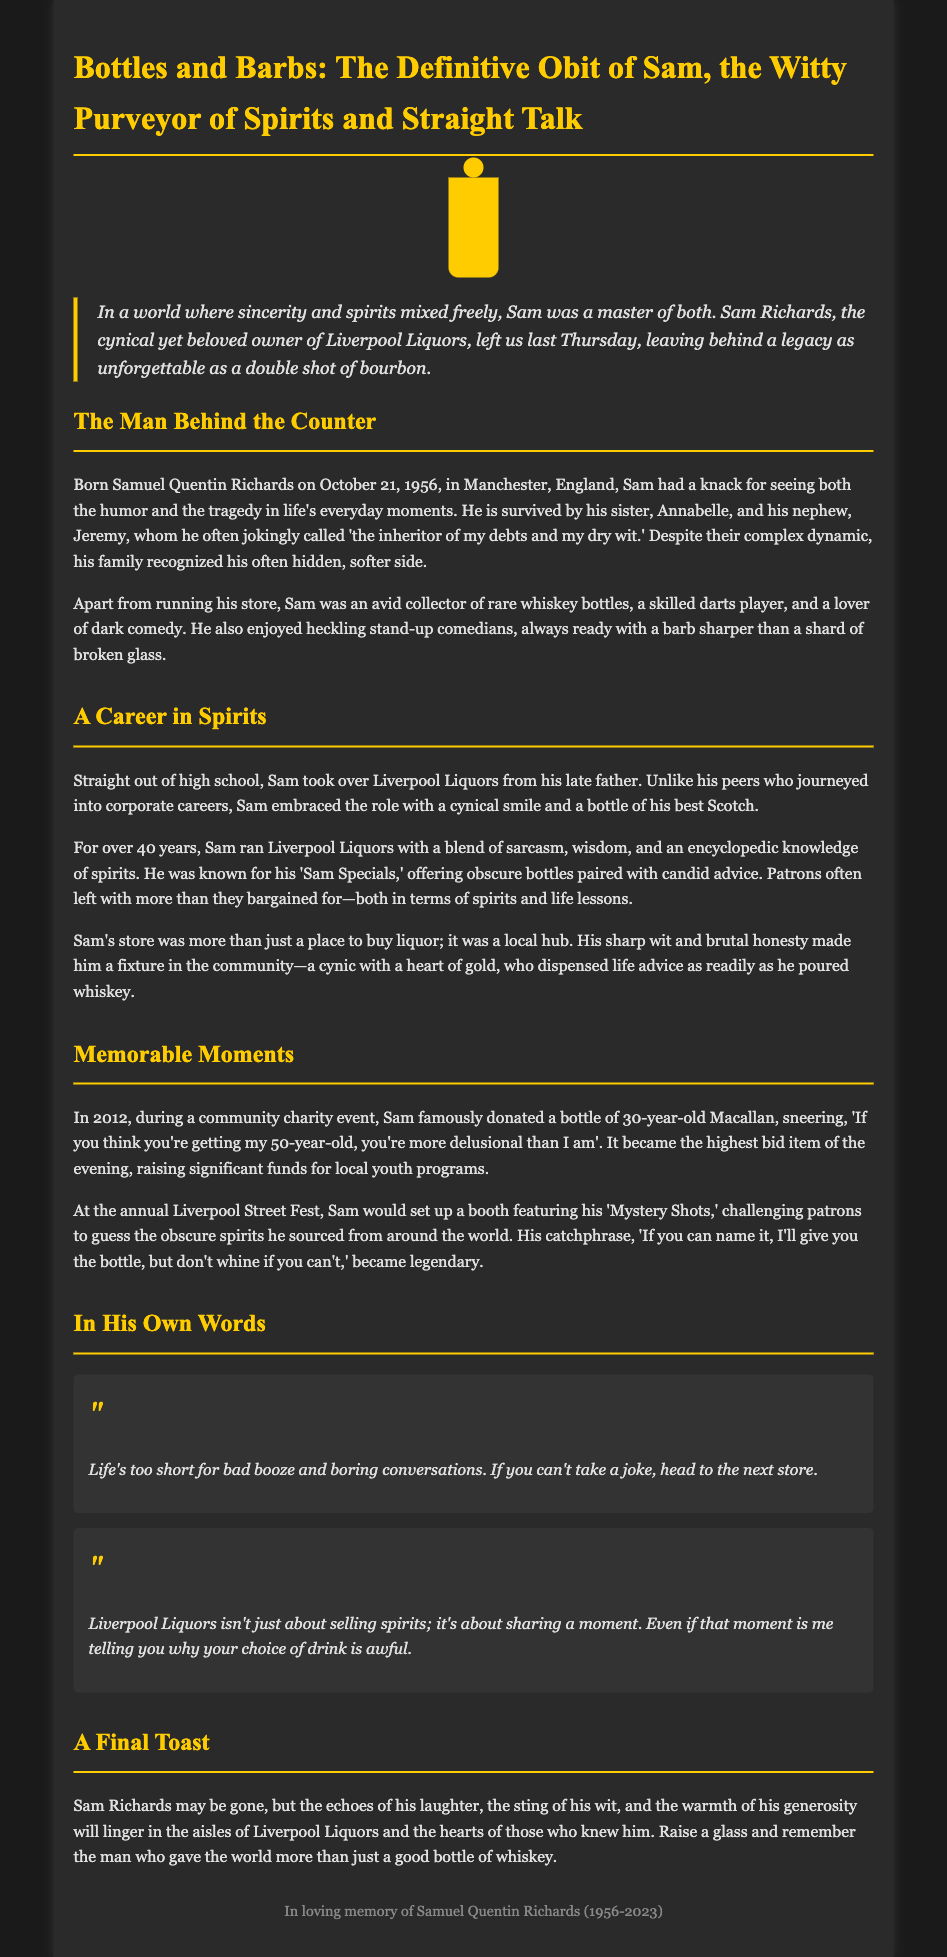what is the full name of the person being remembered? The obituary mentions the full name of the individual as Samuel Quentin Richards.
Answer: Samuel Quentin Richards what date was Sam born? The document states Sam's birth date as October 21, 1956.
Answer: October 21, 1956 what is the name of Sam's liquor store? The obituary indicates that Sam owned a liquor store called Liverpool Liquors.
Answer: Liverpool Liquors how many years did Sam run his liquor store? The document specifies that Sam ran Liverpool Liquors for over 40 years.
Answer: over 40 years who did Sam often call 'the inheritor of my debts and my dry wit'? The obituary mentions that Sam jokingly referred to his nephew Jeremy as 'the inheritor of my debts and my dry wit.'
Answer: Jeremy what was one of Sam's famous catchphrases at the Liverpool Street Fest? The document includes Sam's catchphrase, 'If you can name it, I'll give you the bottle, but don't whine if you can't.'
Answer: If you can name it, I'll give you the bottle, but don't whine if you can't what type of donations did Sam make during a charity event in 2012? The obituary highlights that Sam donated a bottle of 30-year-old Macallan during the charity event.
Answer: a bottle of 30-year-old Macallan what is Sam's view on life according to his own words? In his words, Sam emphasizes that 'Life's too short for bad booze and boring conversations.'
Answer: Life's too short for bad booze and boring conversations what is the intended emotional impact of the obituary on readers? The obituary aims to celebrate Sam's legacy, evoking memories of laughter and warmth among those who knew him.
Answer: celebrate Sam's legacy 